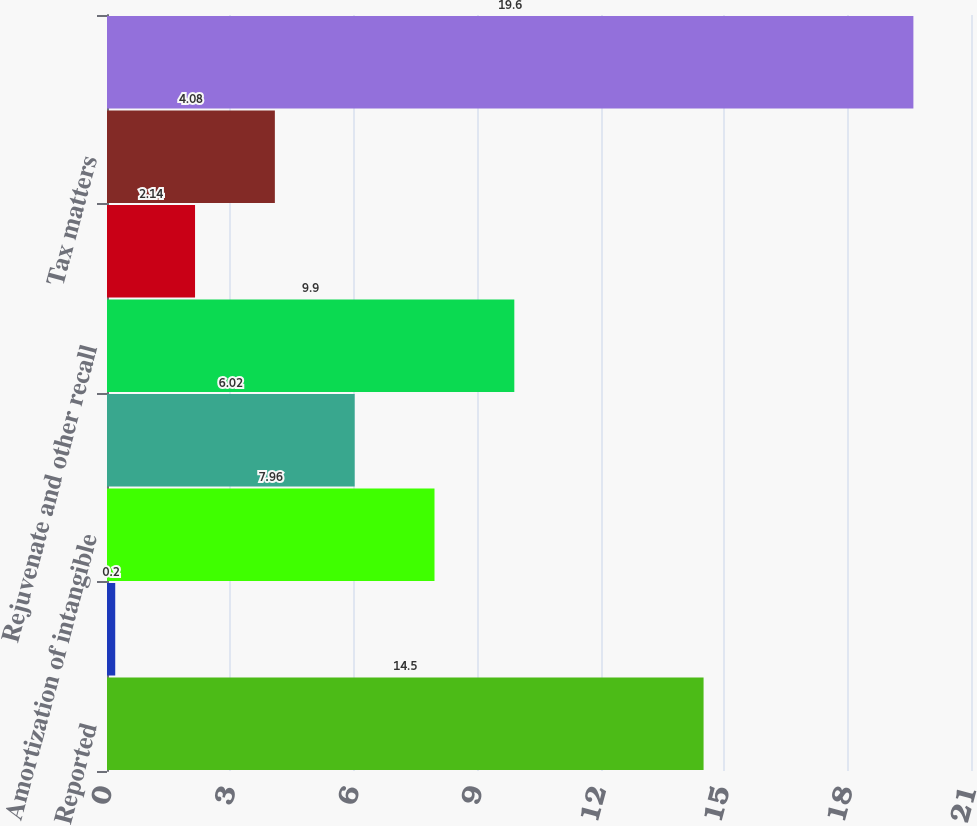Convert chart. <chart><loc_0><loc_0><loc_500><loc_500><bar_chart><fcel>Reported<fcel>Other acquisition and<fcel>Amortization of intangible<fcel>Restructuring- related and<fcel>Rejuvenate and other recall<fcel>Regulatory and legal matters<fcel>Tax matters<fcel>Adjusted<nl><fcel>14.5<fcel>0.2<fcel>7.96<fcel>6.02<fcel>9.9<fcel>2.14<fcel>4.08<fcel>19.6<nl></chart> 